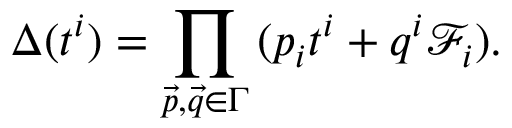Convert formula to latex. <formula><loc_0><loc_0><loc_500><loc_500>\Delta ( t ^ { i } ) = \prod _ { \vec { p } , \vec { q } \in \Gamma } \, ( p _ { i } t ^ { i } + q ^ { i } \mathcal { F } _ { i } ) .</formula> 